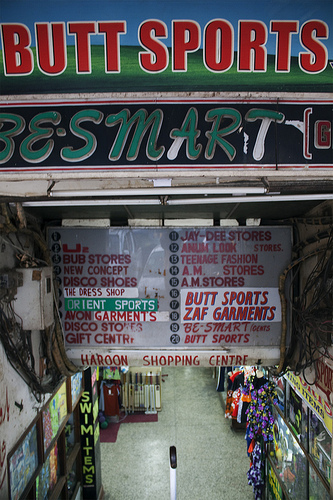<image>
Can you confirm if the floor is under the list? Yes. The floor is positioned underneath the list, with the list above it in the vertical space. 